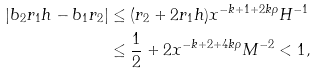Convert formula to latex. <formula><loc_0><loc_0><loc_500><loc_500>\left | b _ { 2 } r _ { 1 } h - b _ { 1 } r _ { 2 } \right | & \leq ( r _ { 2 } + 2 r _ { 1 } h ) x ^ { - k + 1 + 2 k \rho } H ^ { - 1 } \\ & \leq { \frac { 1 } { 2 } } + 2 x ^ { - k + 2 + 4 k \rho } M ^ { - 2 } < 1 ,</formula> 